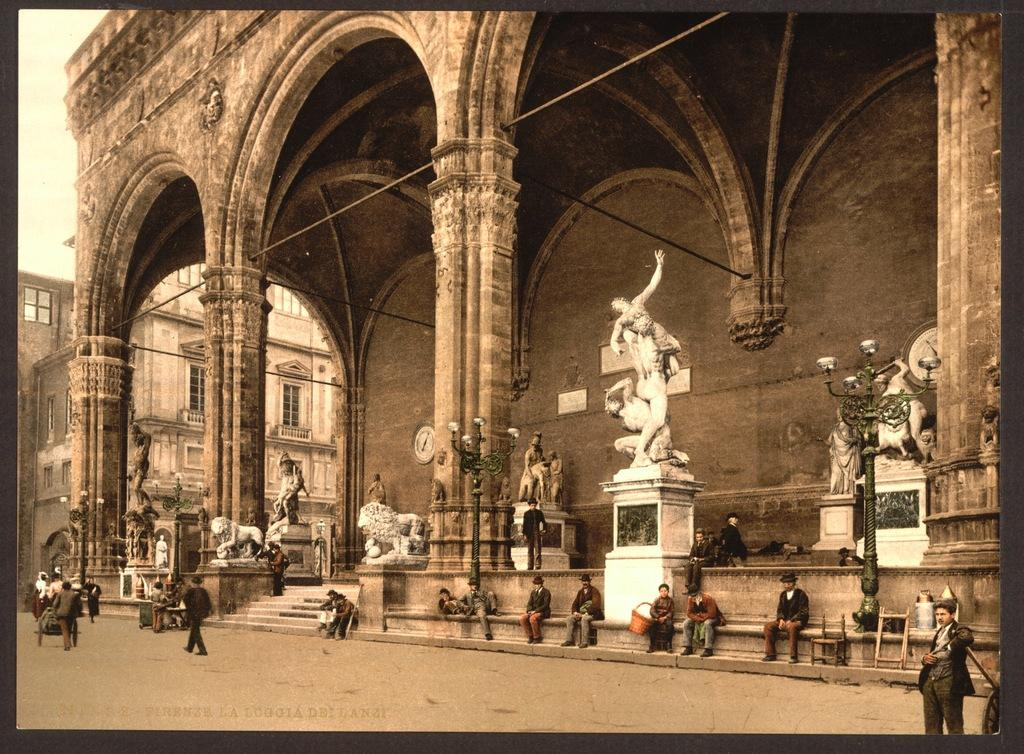What is located in the center of the image? There are buildings in the center of the image. What other objects can be seen in the image? There are statues in the image. What are the people in the image doing? There are people sitting in the image. What is at the bottom of the image? There is a road at the bottom of the image. What are the people on the road doing? There are people walking on the road. What color is the duck in the image? There is no duck present in the image. Why are the people sitting in the image crying? There is no indication in the image that the people are crying; they are simply sitting. 